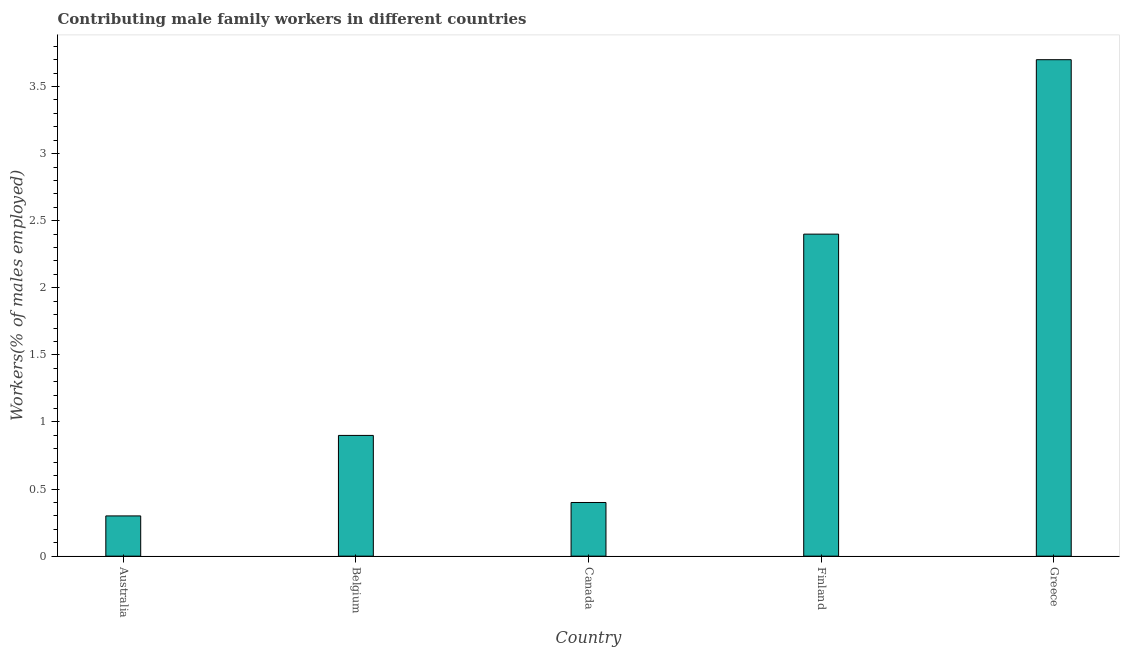What is the title of the graph?
Your response must be concise. Contributing male family workers in different countries. What is the label or title of the Y-axis?
Offer a terse response. Workers(% of males employed). What is the contributing male family workers in Australia?
Your response must be concise. 0.3. Across all countries, what is the maximum contributing male family workers?
Give a very brief answer. 3.7. Across all countries, what is the minimum contributing male family workers?
Your response must be concise. 0.3. In which country was the contributing male family workers maximum?
Make the answer very short. Greece. In which country was the contributing male family workers minimum?
Your response must be concise. Australia. What is the sum of the contributing male family workers?
Keep it short and to the point. 7.7. What is the difference between the contributing male family workers in Belgium and Finland?
Offer a terse response. -1.5. What is the average contributing male family workers per country?
Your answer should be very brief. 1.54. What is the median contributing male family workers?
Make the answer very short. 0.9. What is the ratio of the contributing male family workers in Belgium to that in Greece?
Your answer should be very brief. 0.24. Is the contributing male family workers in Canada less than that in Finland?
Offer a very short reply. Yes. What is the difference between the highest and the second highest contributing male family workers?
Offer a very short reply. 1.3. In how many countries, is the contributing male family workers greater than the average contributing male family workers taken over all countries?
Your answer should be very brief. 2. How many bars are there?
Keep it short and to the point. 5. Are the values on the major ticks of Y-axis written in scientific E-notation?
Make the answer very short. No. What is the Workers(% of males employed) of Australia?
Keep it short and to the point. 0.3. What is the Workers(% of males employed) of Belgium?
Your answer should be compact. 0.9. What is the Workers(% of males employed) of Canada?
Offer a terse response. 0.4. What is the Workers(% of males employed) of Finland?
Offer a very short reply. 2.4. What is the Workers(% of males employed) of Greece?
Give a very brief answer. 3.7. What is the difference between the Workers(% of males employed) in Australia and Canada?
Your answer should be compact. -0.1. What is the difference between the Workers(% of males employed) in Australia and Finland?
Give a very brief answer. -2.1. What is the difference between the Workers(% of males employed) in Belgium and Greece?
Offer a terse response. -2.8. What is the difference between the Workers(% of males employed) in Canada and Finland?
Your response must be concise. -2. What is the difference between the Workers(% of males employed) in Finland and Greece?
Keep it short and to the point. -1.3. What is the ratio of the Workers(% of males employed) in Australia to that in Belgium?
Ensure brevity in your answer.  0.33. What is the ratio of the Workers(% of males employed) in Australia to that in Canada?
Provide a succinct answer. 0.75. What is the ratio of the Workers(% of males employed) in Australia to that in Finland?
Your answer should be compact. 0.12. What is the ratio of the Workers(% of males employed) in Australia to that in Greece?
Make the answer very short. 0.08. What is the ratio of the Workers(% of males employed) in Belgium to that in Canada?
Ensure brevity in your answer.  2.25. What is the ratio of the Workers(% of males employed) in Belgium to that in Greece?
Your response must be concise. 0.24. What is the ratio of the Workers(% of males employed) in Canada to that in Finland?
Give a very brief answer. 0.17. What is the ratio of the Workers(% of males employed) in Canada to that in Greece?
Make the answer very short. 0.11. What is the ratio of the Workers(% of males employed) in Finland to that in Greece?
Offer a terse response. 0.65. 